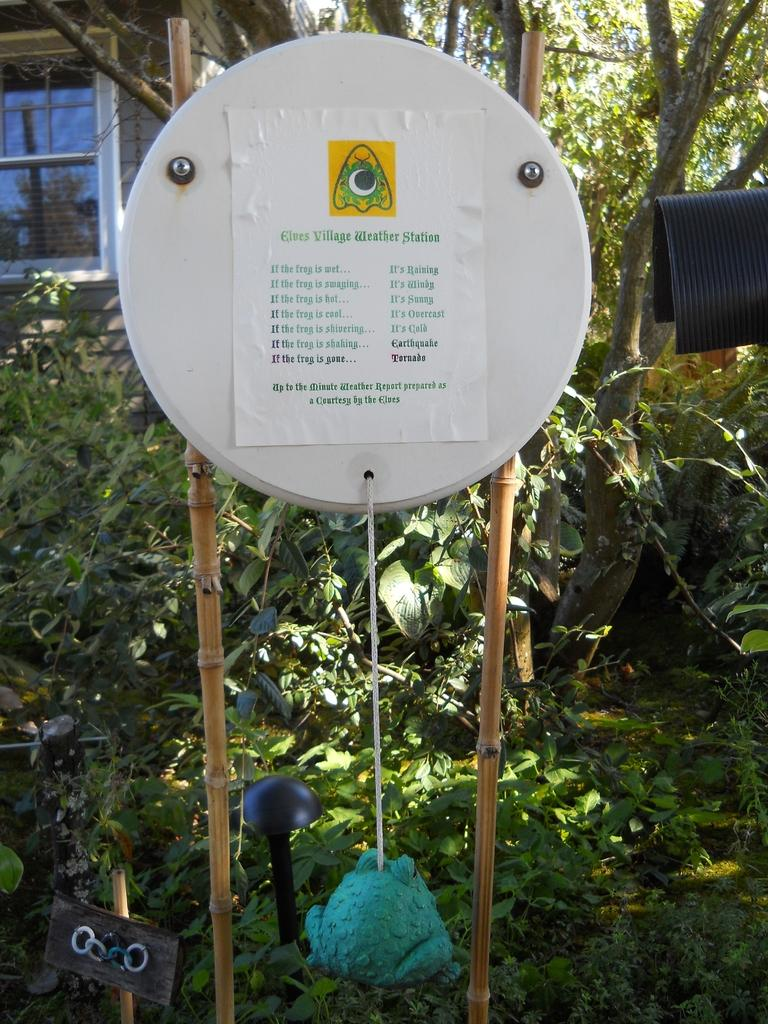What is on the board in the image? There is a poster on a board in the image. What type of living organisms can be seen in the image? Plants are visible in the image. What can be found on the ground in the image? There are objects on the ground in the image. What is in the background of the image? There is a wall with a window and trees are visible in the background of the image. What type of cabbage is growing in the image? There is no cabbage present in the image. How many bulbs are visible in the image? There are no bulbs visible in the image. 